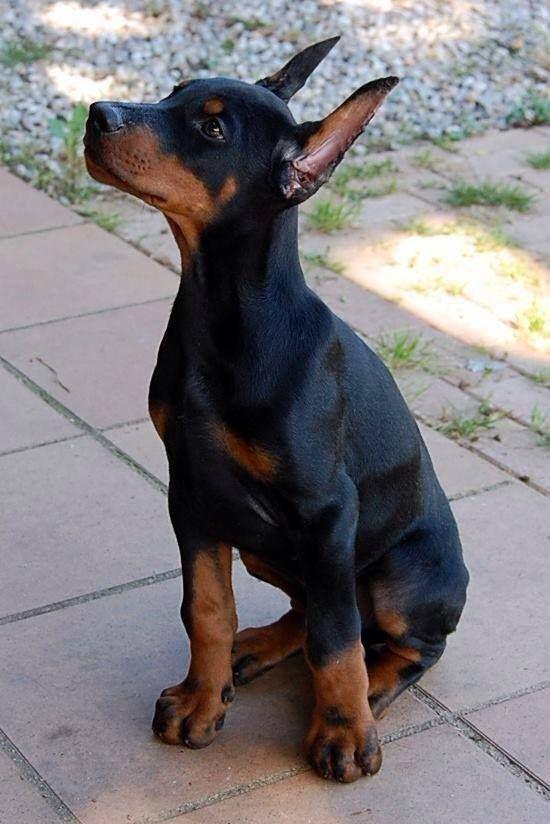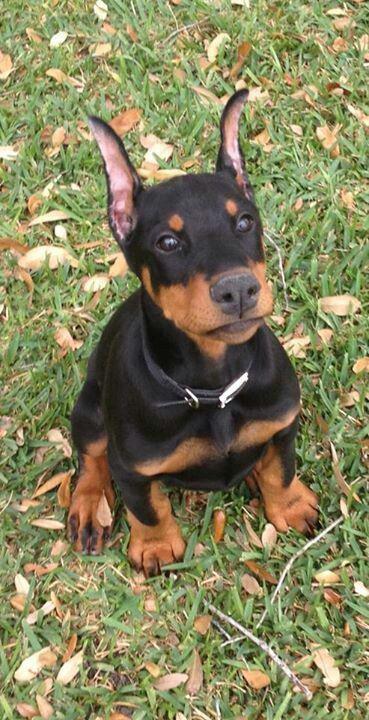The first image is the image on the left, the second image is the image on the right. For the images shown, is this caption "One of the dogs has uncropped ears." true? Answer yes or no. No. 